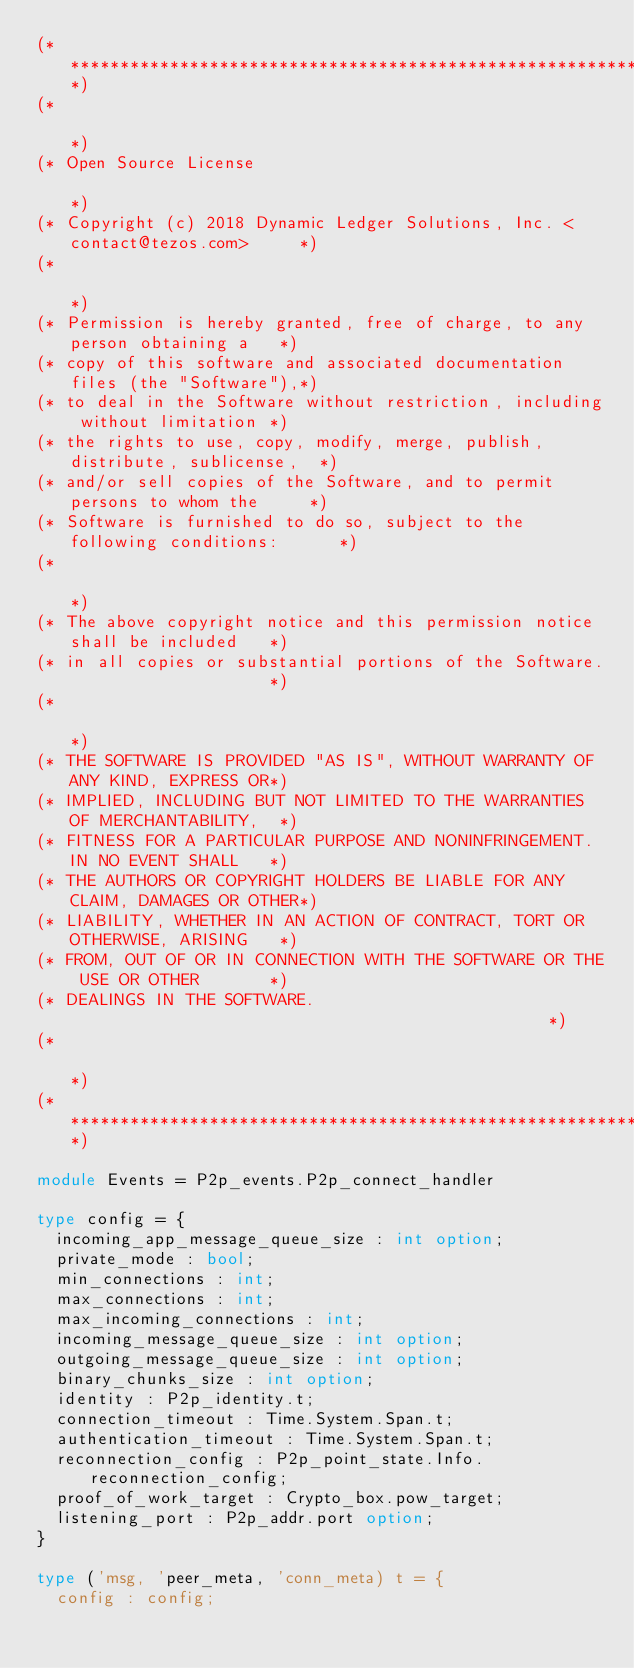<code> <loc_0><loc_0><loc_500><loc_500><_OCaml_>(*****************************************************************************)
(*                                                                           *)
(* Open Source License                                                       *)
(* Copyright (c) 2018 Dynamic Ledger Solutions, Inc. <contact@tezos.com>     *)
(*                                                                           *)
(* Permission is hereby granted, free of charge, to any person obtaining a   *)
(* copy of this software and associated documentation files (the "Software"),*)
(* to deal in the Software without restriction, including without limitation *)
(* the rights to use, copy, modify, merge, publish, distribute, sublicense,  *)
(* and/or sell copies of the Software, and to permit persons to whom the     *)
(* Software is furnished to do so, subject to the following conditions:      *)
(*                                                                           *)
(* The above copyright notice and this permission notice shall be included   *)
(* in all copies or substantial portions of the Software.                    *)
(*                                                                           *)
(* THE SOFTWARE IS PROVIDED "AS IS", WITHOUT WARRANTY OF ANY KIND, EXPRESS OR*)
(* IMPLIED, INCLUDING BUT NOT LIMITED TO THE WARRANTIES OF MERCHANTABILITY,  *)
(* FITNESS FOR A PARTICULAR PURPOSE AND NONINFRINGEMENT. IN NO EVENT SHALL   *)
(* THE AUTHORS OR COPYRIGHT HOLDERS BE LIABLE FOR ANY CLAIM, DAMAGES OR OTHER*)
(* LIABILITY, WHETHER IN AN ACTION OF CONTRACT, TORT OR OTHERWISE, ARISING   *)
(* FROM, OUT OF OR IN CONNECTION WITH THE SOFTWARE OR THE USE OR OTHER       *)
(* DEALINGS IN THE SOFTWARE.                                                 *)
(*                                                                           *)
(*****************************************************************************)

module Events = P2p_events.P2p_connect_handler

type config = {
  incoming_app_message_queue_size : int option;
  private_mode : bool;
  min_connections : int;
  max_connections : int;
  max_incoming_connections : int;
  incoming_message_queue_size : int option;
  outgoing_message_queue_size : int option;
  binary_chunks_size : int option;
  identity : P2p_identity.t;
  connection_timeout : Time.System.Span.t;
  authentication_timeout : Time.System.Span.t;
  reconnection_config : P2p_point_state.Info.reconnection_config;
  proof_of_work_target : Crypto_box.pow_target;
  listening_port : P2p_addr.port option;
}

type ('msg, 'peer_meta, 'conn_meta) t = {
  config : config;</code> 